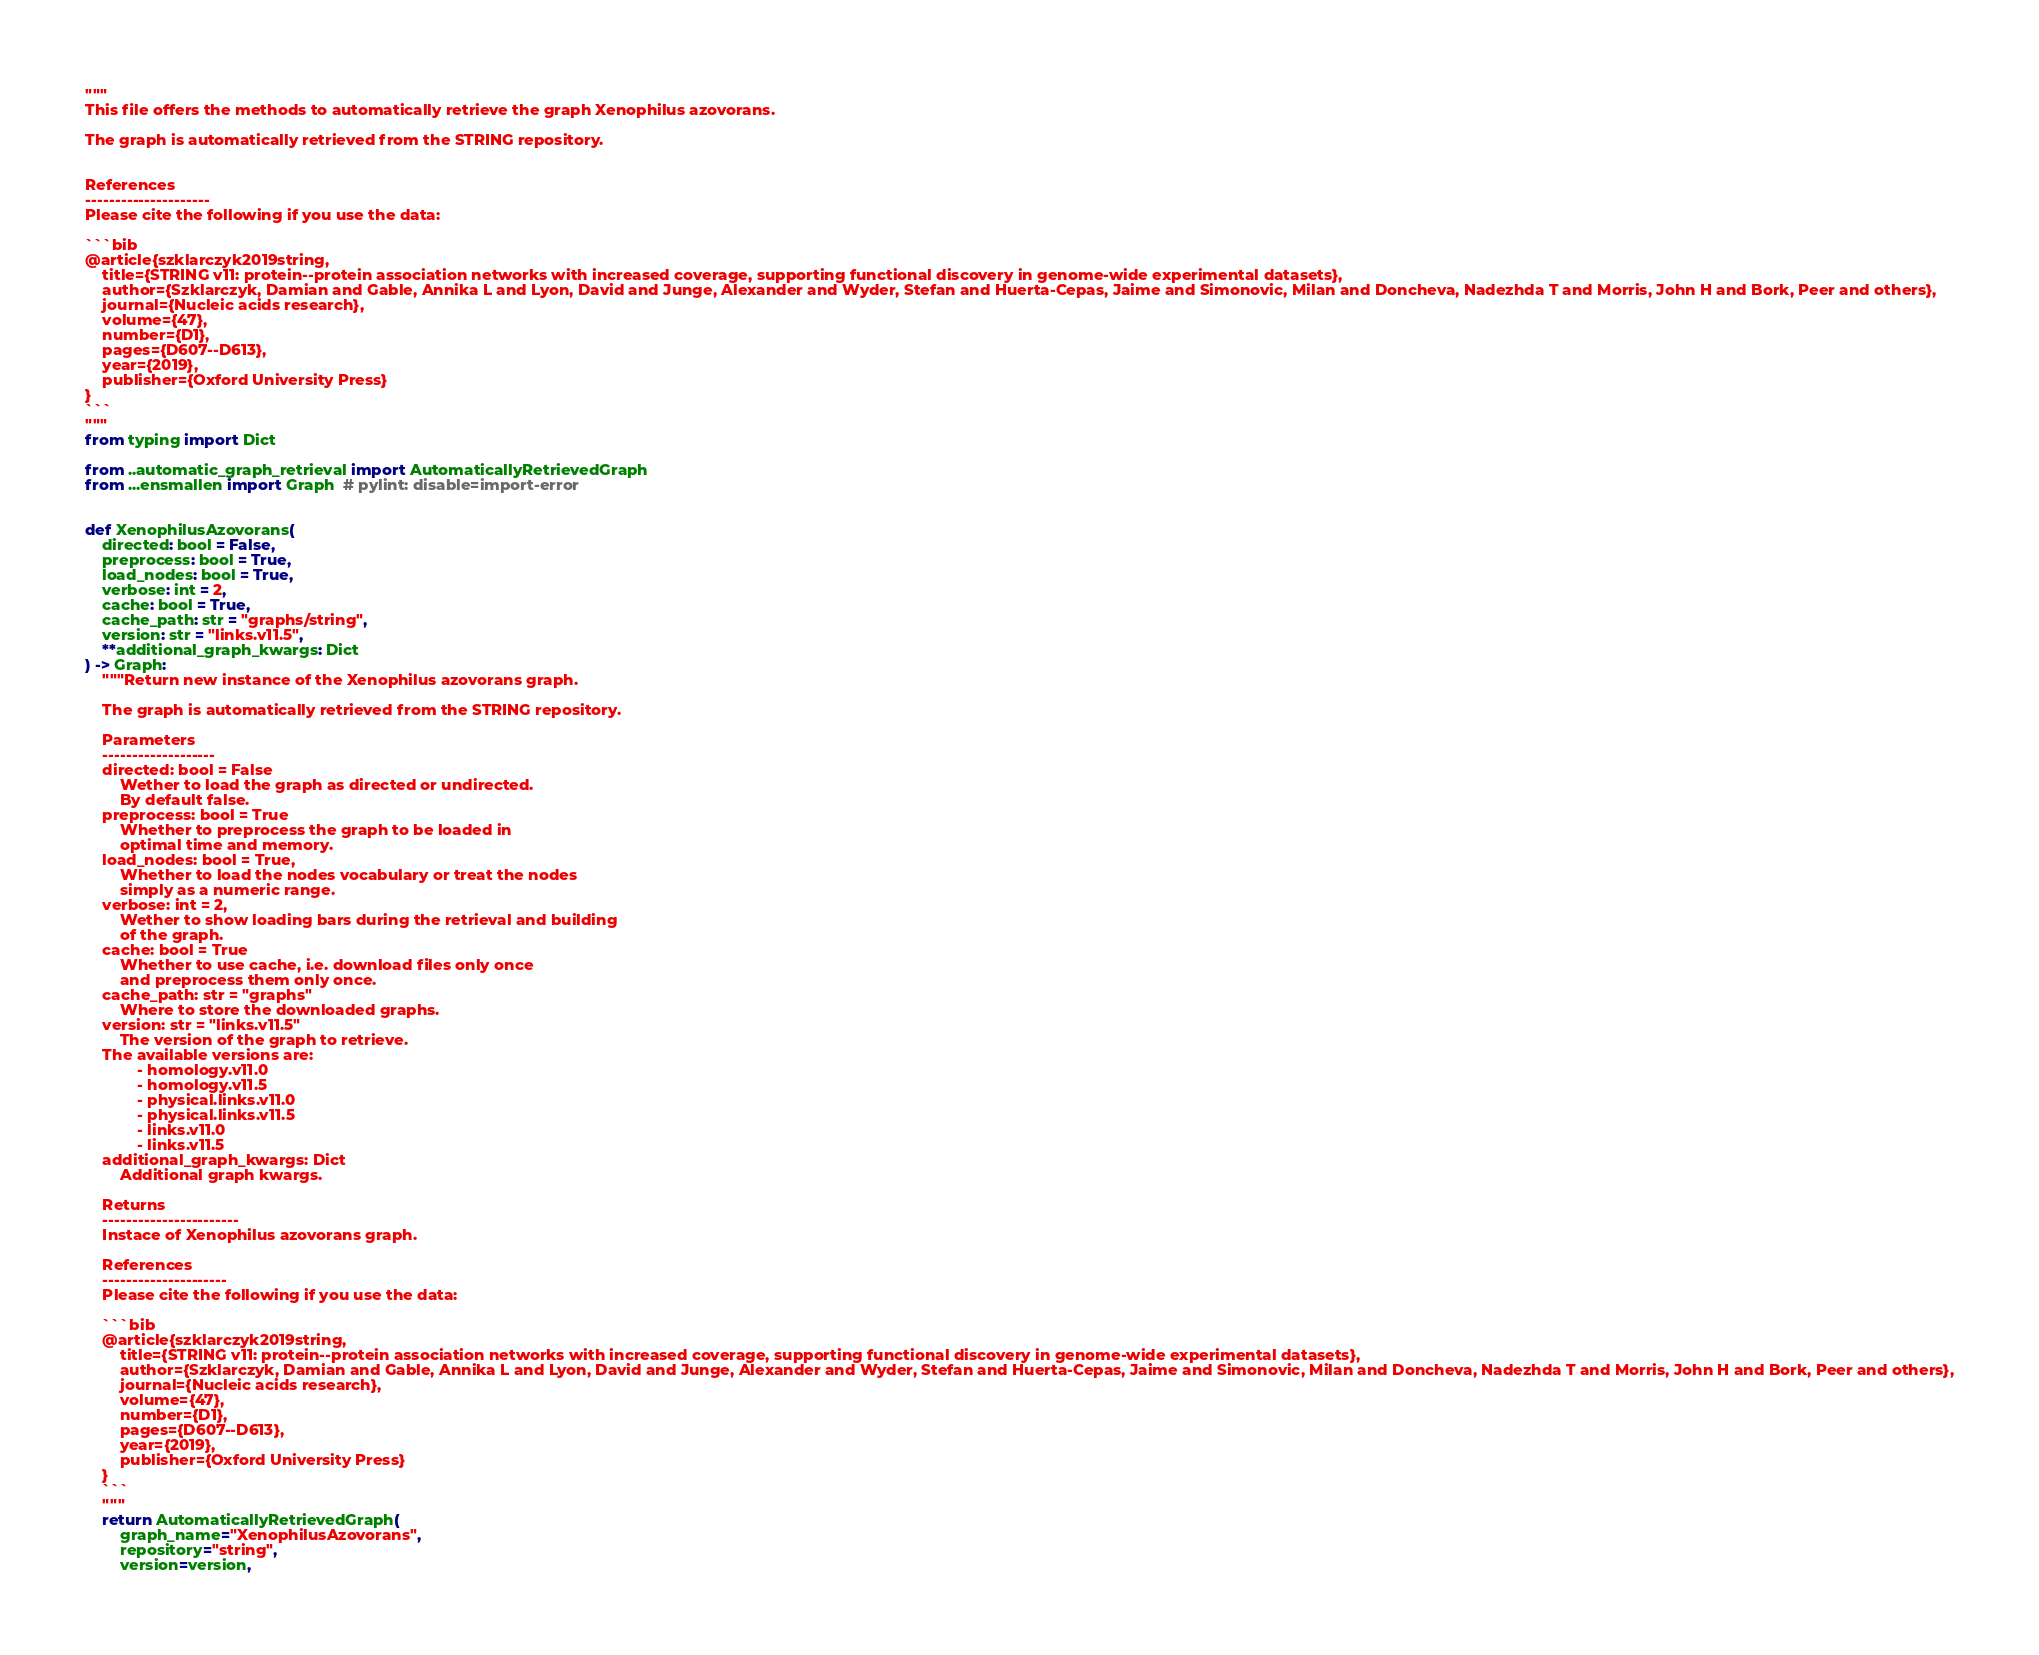Convert code to text. <code><loc_0><loc_0><loc_500><loc_500><_Python_>"""
This file offers the methods to automatically retrieve the graph Xenophilus azovorans.

The graph is automatically retrieved from the STRING repository. 


References
---------------------
Please cite the following if you use the data:

```bib
@article{szklarczyk2019string,
    title={STRING v11: protein--protein association networks with increased coverage, supporting functional discovery in genome-wide experimental datasets},
    author={Szklarczyk, Damian and Gable, Annika L and Lyon, David and Junge, Alexander and Wyder, Stefan and Huerta-Cepas, Jaime and Simonovic, Milan and Doncheva, Nadezhda T and Morris, John H and Bork, Peer and others},
    journal={Nucleic acids research},
    volume={47},
    number={D1},
    pages={D607--D613},
    year={2019},
    publisher={Oxford University Press}
}
```
"""
from typing import Dict

from ..automatic_graph_retrieval import AutomaticallyRetrievedGraph
from ...ensmallen import Graph  # pylint: disable=import-error


def XenophilusAzovorans(
    directed: bool = False,
    preprocess: bool = True,
    load_nodes: bool = True,
    verbose: int = 2,
    cache: bool = True,
    cache_path: str = "graphs/string",
    version: str = "links.v11.5",
    **additional_graph_kwargs: Dict
) -> Graph:
    """Return new instance of the Xenophilus azovorans graph.

    The graph is automatically retrieved from the STRING repository.	

    Parameters
    -------------------
    directed: bool = False
        Wether to load the graph as directed or undirected.
        By default false.
    preprocess: bool = True
        Whether to preprocess the graph to be loaded in 
        optimal time and memory.
    load_nodes: bool = True,
        Whether to load the nodes vocabulary or treat the nodes
        simply as a numeric range.
    verbose: int = 2,
        Wether to show loading bars during the retrieval and building
        of the graph.
    cache: bool = True
        Whether to use cache, i.e. download files only once
        and preprocess them only once.
    cache_path: str = "graphs"
        Where to store the downloaded graphs.
    version: str = "links.v11.5"
        The version of the graph to retrieve.		
	The available versions are:
			- homology.v11.0
			- homology.v11.5
			- physical.links.v11.0
			- physical.links.v11.5
			- links.v11.0
			- links.v11.5
    additional_graph_kwargs: Dict
        Additional graph kwargs.

    Returns
    -----------------------
    Instace of Xenophilus azovorans graph.

	References
	---------------------
	Please cite the following if you use the data:
	
	```bib
	@article{szklarczyk2019string,
	    title={STRING v11: protein--protein association networks with increased coverage, supporting functional discovery in genome-wide experimental datasets},
	    author={Szklarczyk, Damian and Gable, Annika L and Lyon, David and Junge, Alexander and Wyder, Stefan and Huerta-Cepas, Jaime and Simonovic, Milan and Doncheva, Nadezhda T and Morris, John H and Bork, Peer and others},
	    journal={Nucleic acids research},
	    volume={47},
	    number={D1},
	    pages={D607--D613},
	    year={2019},
	    publisher={Oxford University Press}
	}
	```
    """
    return AutomaticallyRetrievedGraph(
        graph_name="XenophilusAzovorans",
        repository="string",
        version=version,</code> 